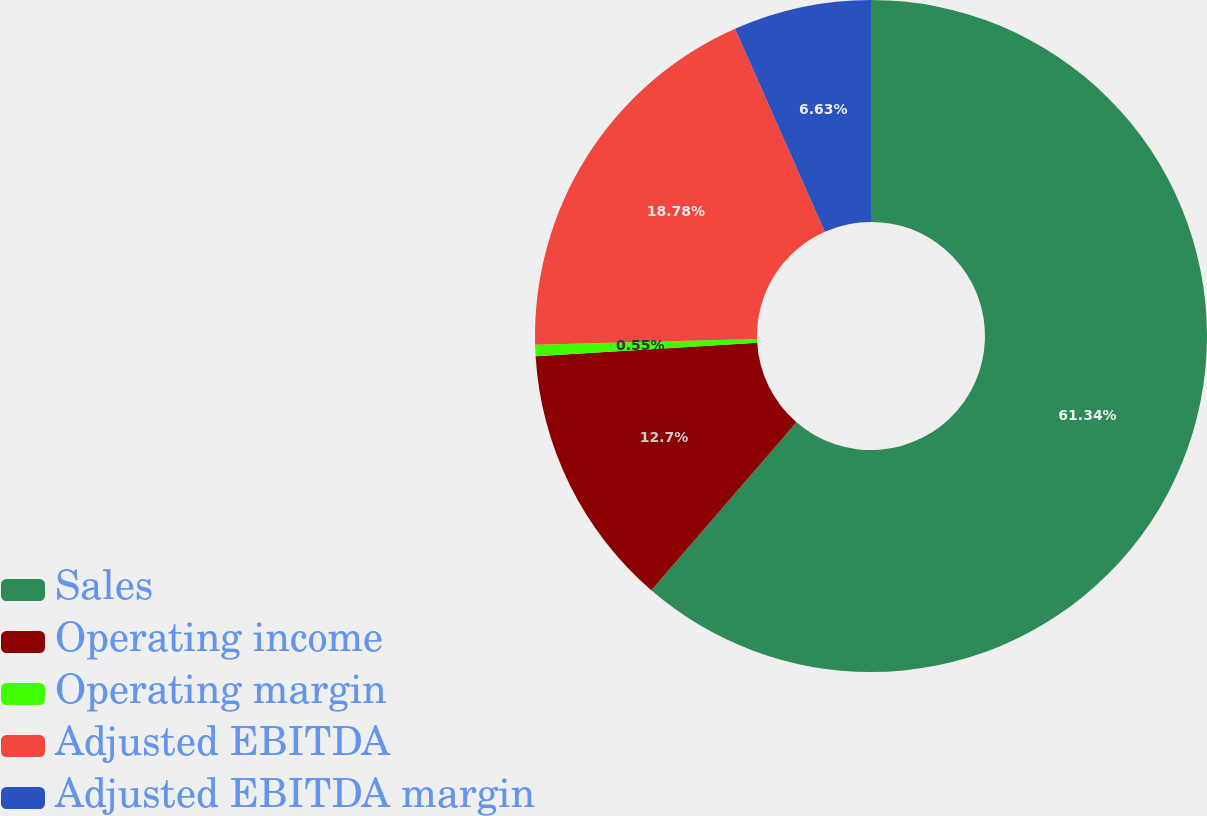Convert chart to OTSL. <chart><loc_0><loc_0><loc_500><loc_500><pie_chart><fcel>Sales<fcel>Operating income<fcel>Operating margin<fcel>Adjusted EBITDA<fcel>Adjusted EBITDA margin<nl><fcel>61.34%<fcel>12.7%<fcel>0.55%<fcel>18.78%<fcel>6.63%<nl></chart> 